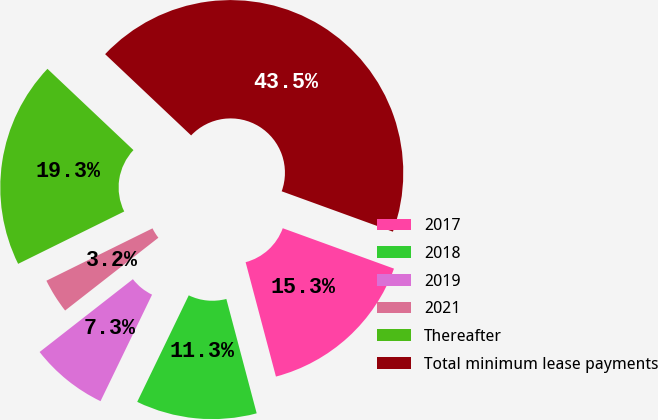Convert chart to OTSL. <chart><loc_0><loc_0><loc_500><loc_500><pie_chart><fcel>2017<fcel>2018<fcel>2019<fcel>2021<fcel>Thereafter<fcel>Total minimum lease payments<nl><fcel>15.33%<fcel>11.3%<fcel>7.28%<fcel>3.25%<fcel>19.35%<fcel>43.5%<nl></chart> 